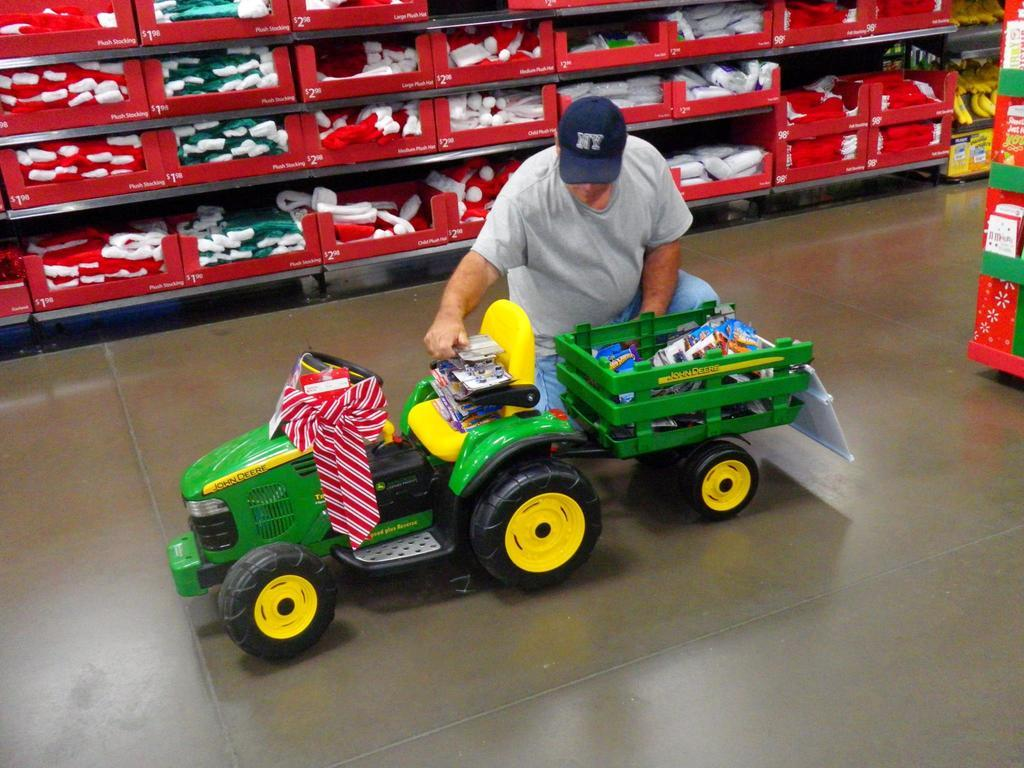What is the position of the person in the image? The person is kneeling down in the image. What object is the person interacting with? The person is interacting with a toy car in the image. What is inside the toy car? The toy car has objects in it. What can be seen in the background of the image? There are aisles filled with objects in cardboard boxes in the background of the image. What type of prison can be seen in the image? There is no prison present in the image; it features a person interacting with a toy car and aisles filled with objects in cardboard boxes. Is there a boat visible in the image? No, there is no boat present in the image. 